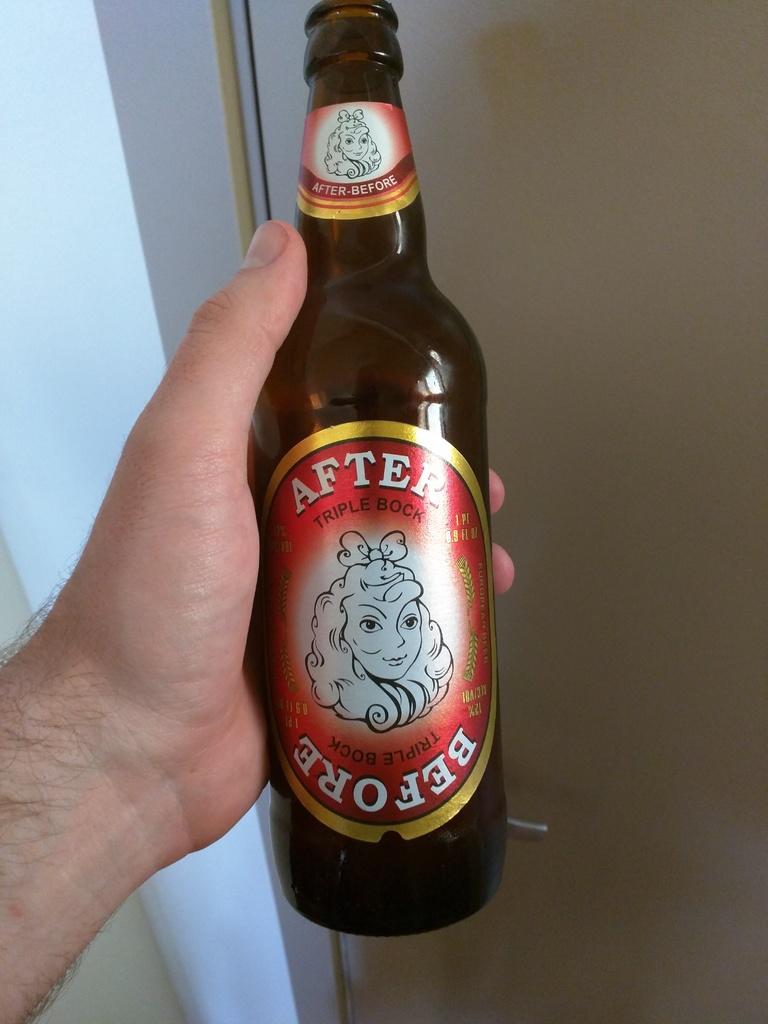What is after, "after" in the name of the beer?
Offer a very short reply. Before. What is the last word of the brand name?
Your answer should be compact. Before. 